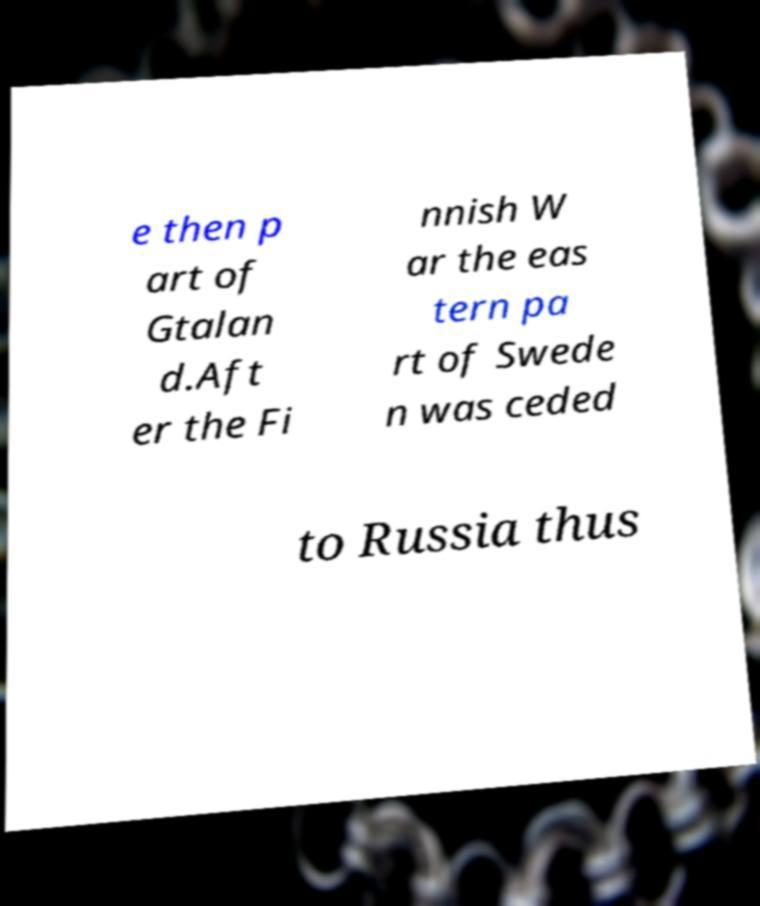For documentation purposes, I need the text within this image transcribed. Could you provide that? e then p art of Gtalan d.Aft er the Fi nnish W ar the eas tern pa rt of Swede n was ceded to Russia thus 